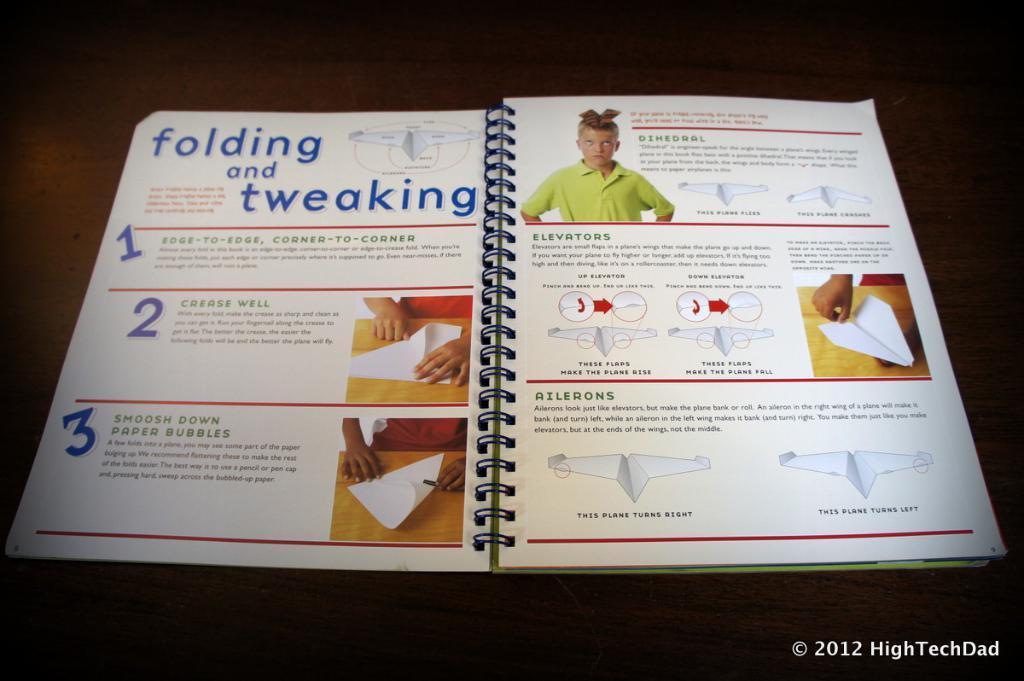Please provide a concise description of this image. In this image I can see a book which is white in color and in the book I can see few pictures in which I can see a person wearing green colored dress, and few hands of person holding white colored paper. I can see the brown colored background. 